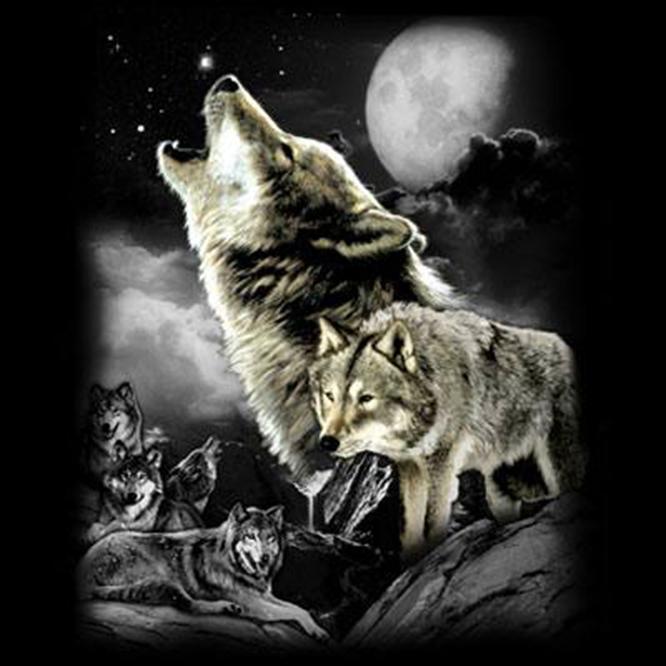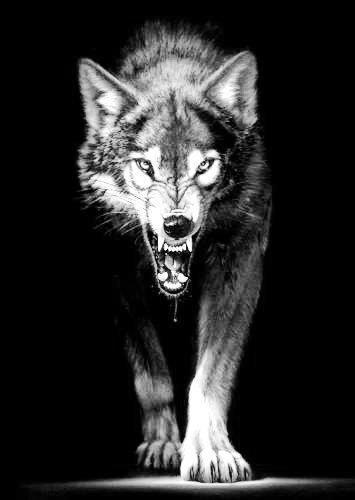The first image is the image on the left, the second image is the image on the right. Evaluate the accuracy of this statement regarding the images: "A single wolf is howling and silhouetted by the moon in one of the images.". Is it true? Answer yes or no. No. The first image is the image on the left, the second image is the image on the right. Examine the images to the left and right. Is the description "The left image includes a moon, clouds, and a howling wolf figure, and the right image depicts a forward-facing snarling wolf." accurate? Answer yes or no. Yes. 